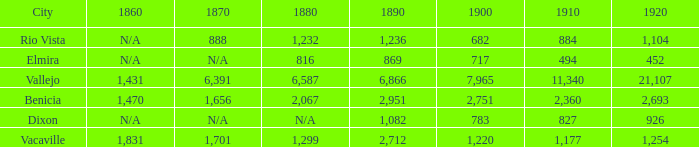What is the 1880 figure when 1860 is N/A and 1910 is 494? 816.0. 